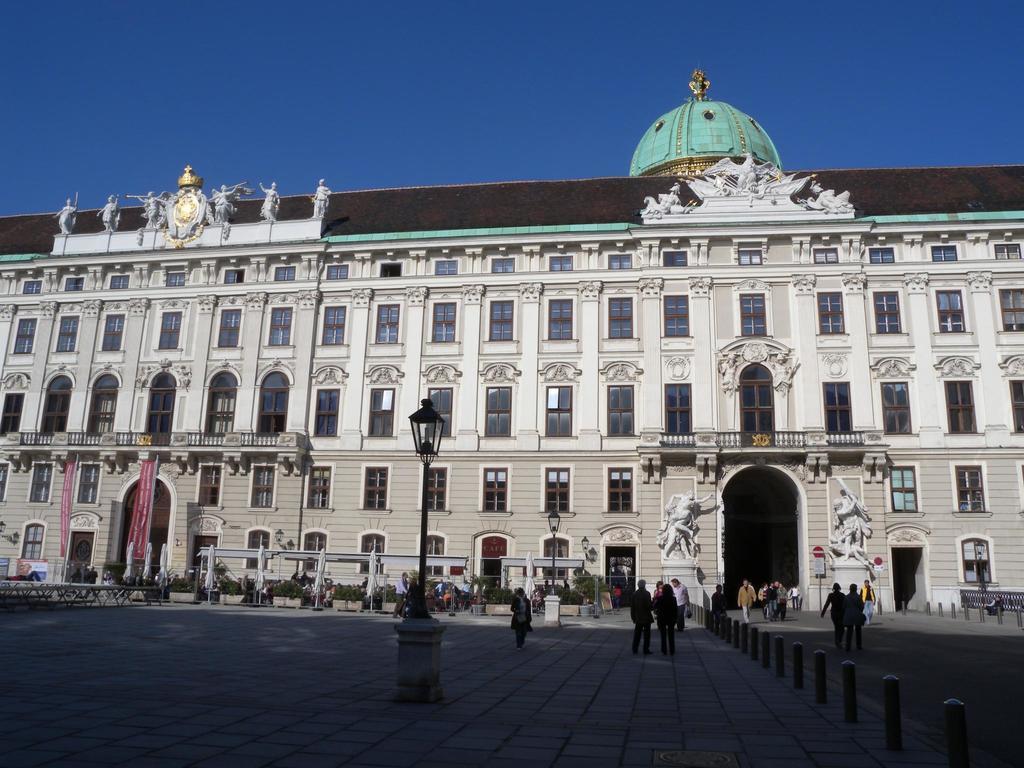How would you summarize this image in a sentence or two? In this image I can see there is a building and a ground where the person walking. And there is a pole with a light and a banner. And there are trees and a fence. And at the top there is a sky. 